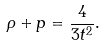<formula> <loc_0><loc_0><loc_500><loc_500>\rho + p = \frac { 4 } { 3 t ^ { 2 } } .</formula> 